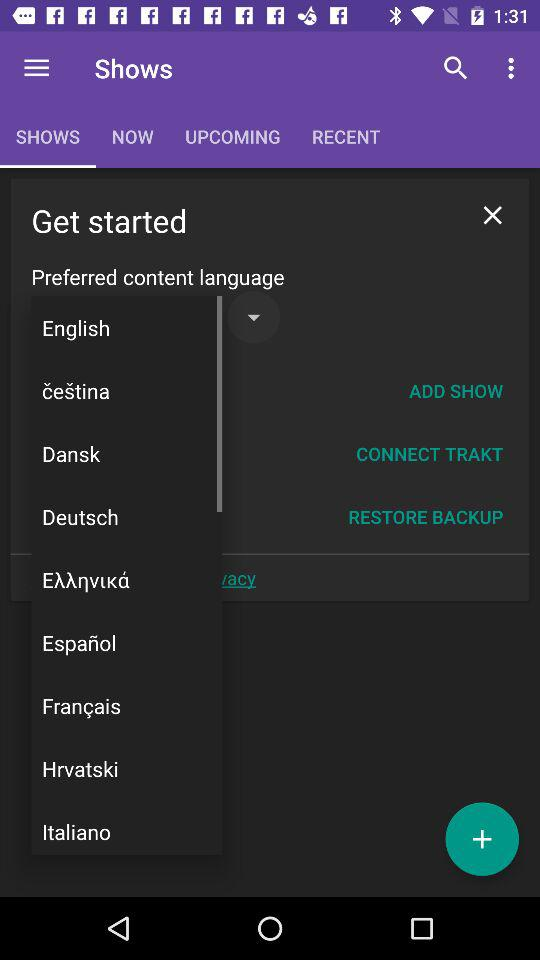Which tab is selected? The selected tab is "SHOWS". 